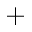Convert formula to latex. <formula><loc_0><loc_0><loc_500><loc_500>^ { + }</formula> 